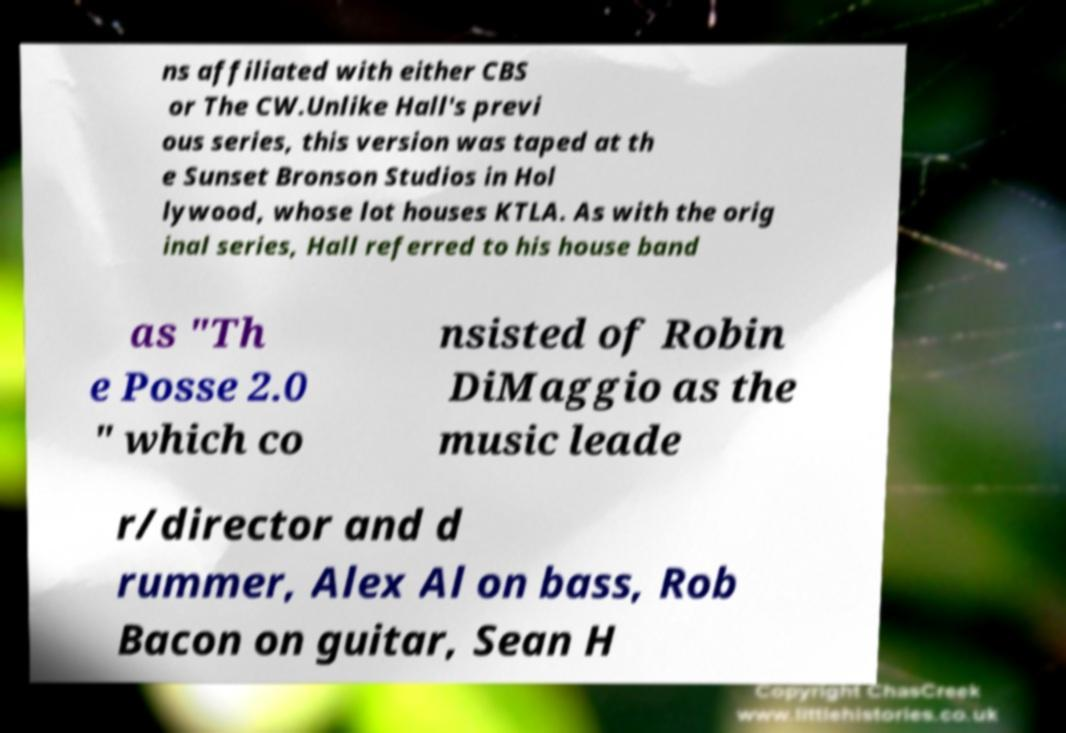Could you assist in decoding the text presented in this image and type it out clearly? ns affiliated with either CBS or The CW.Unlike Hall's previ ous series, this version was taped at th e Sunset Bronson Studios in Hol lywood, whose lot houses KTLA. As with the orig inal series, Hall referred to his house band as "Th e Posse 2.0 " which co nsisted of Robin DiMaggio as the music leade r/director and d rummer, Alex Al on bass, Rob Bacon on guitar, Sean H 